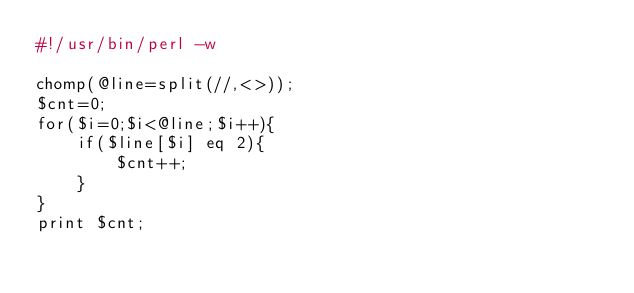Convert code to text. <code><loc_0><loc_0><loc_500><loc_500><_Perl_>#!/usr/bin/perl -w

chomp(@line=split(//,<>));
$cnt=0;
for($i=0;$i<@line;$i++){
    if($line[$i] eq 2){
        $cnt++;
    }
}
print $cnt;</code> 